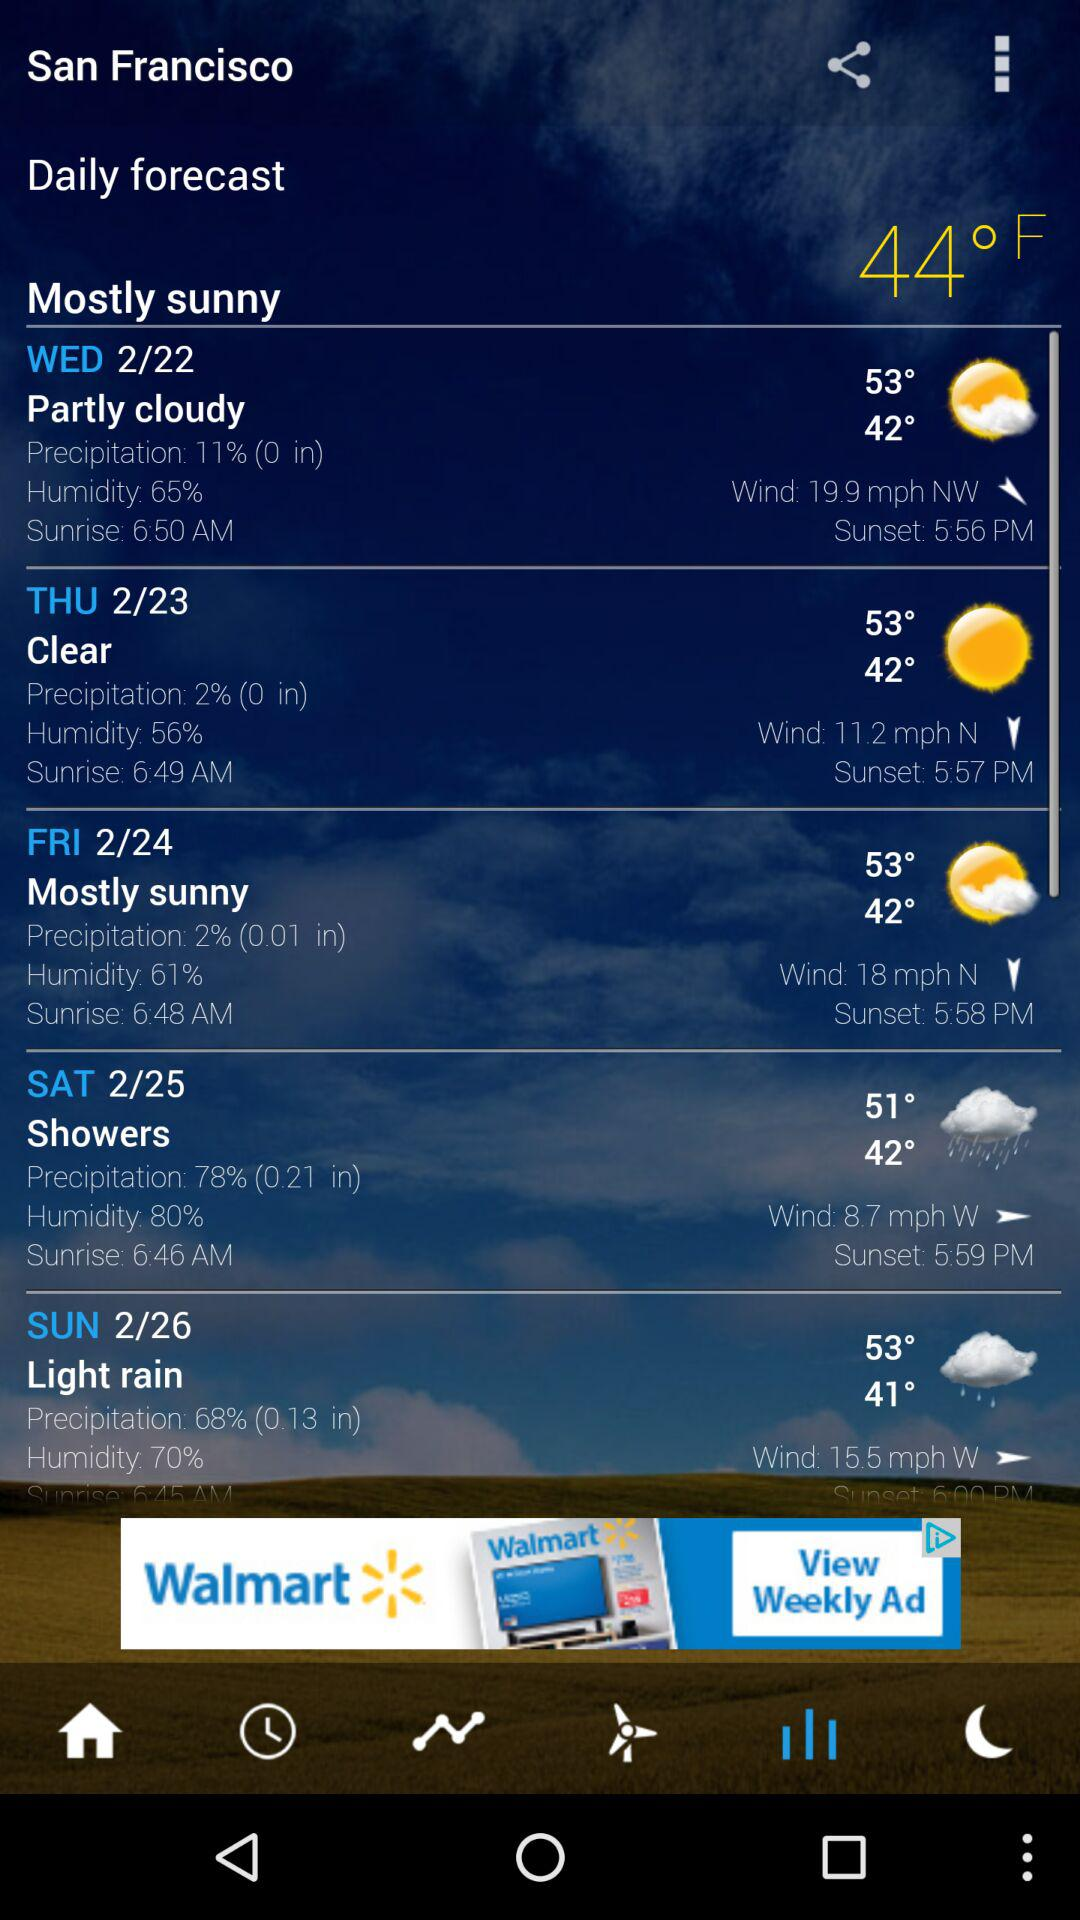What time does the sun set on Friday? The sun sets on Friday at 5:58 PM. 